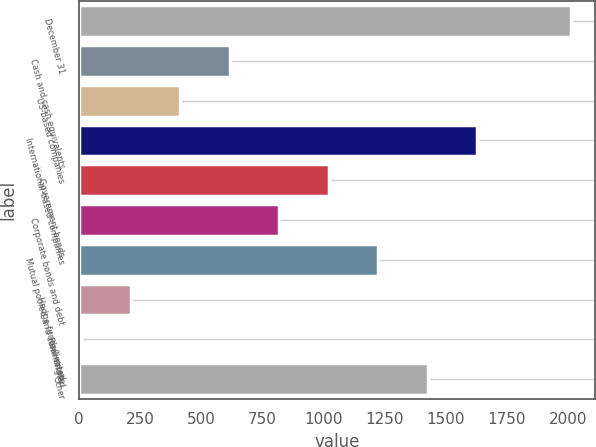Convert chart. <chart><loc_0><loc_0><loc_500><loc_500><bar_chart><fcel>December 31<fcel>Cash and cash equivalents<fcel>US-based companies<fcel>International-based companies<fcel>Government bonds<fcel>Corporate bonds and debt<fcel>Mutual pooled and commingled<fcel>Hedge funds/limited<fcel>Real estate<fcel>Other<nl><fcel>2012<fcel>616.8<fcel>414.2<fcel>1629.8<fcel>1022<fcel>819.4<fcel>1224.6<fcel>211.6<fcel>9<fcel>1427.2<nl></chart> 